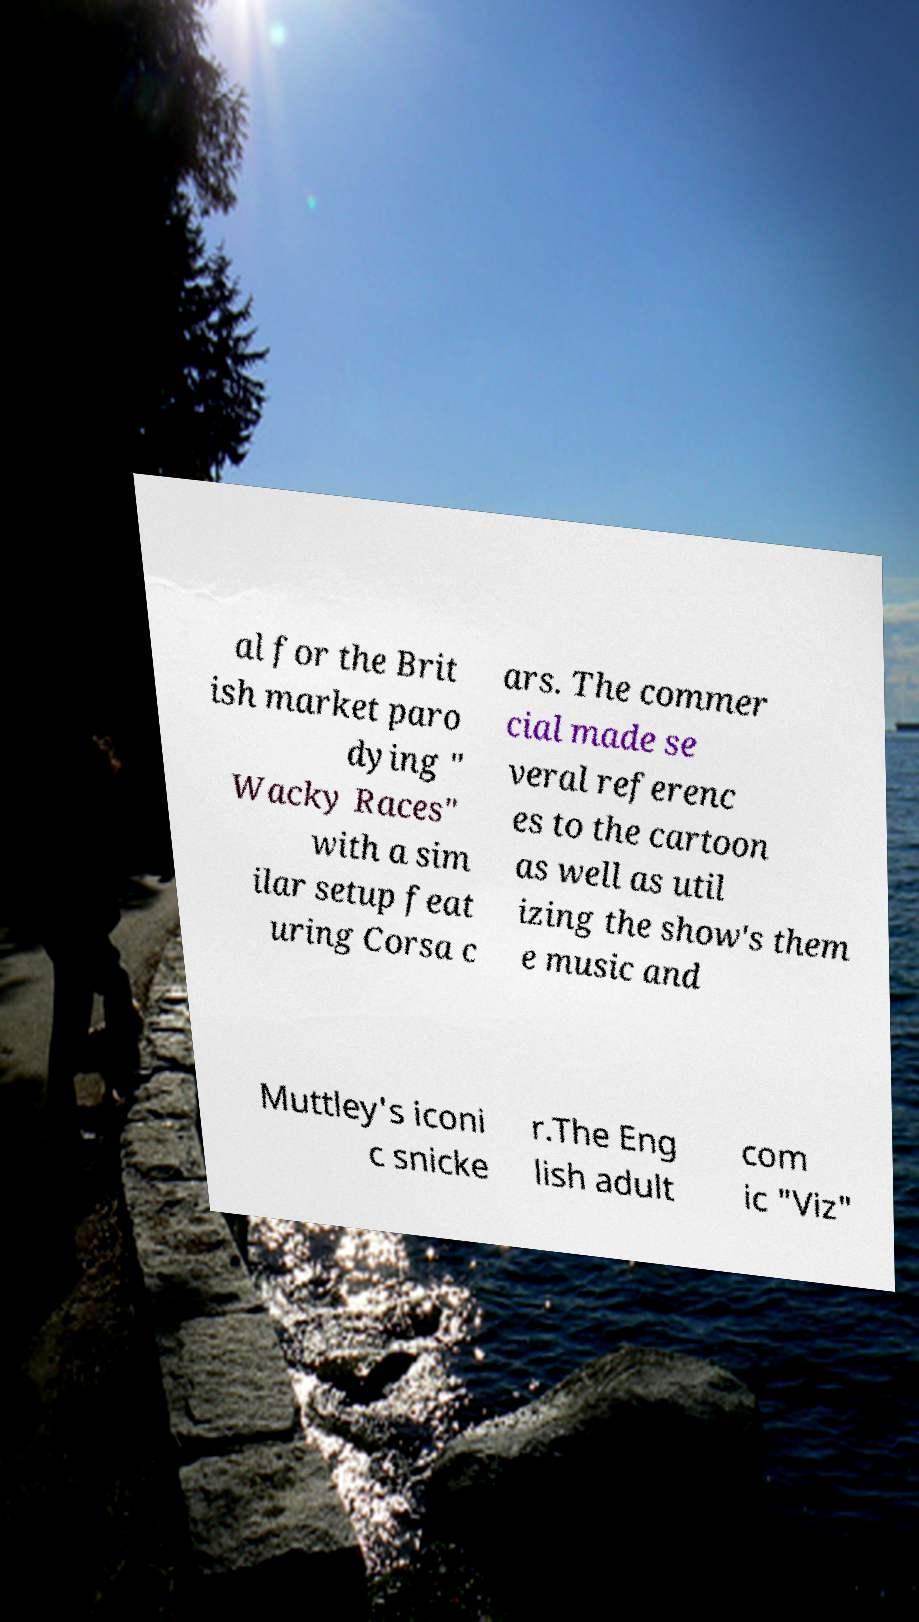What messages or text are displayed in this image? I need them in a readable, typed format. al for the Brit ish market paro dying " Wacky Races" with a sim ilar setup feat uring Corsa c ars. The commer cial made se veral referenc es to the cartoon as well as util izing the show's them e music and Muttley's iconi c snicke r.The Eng lish adult com ic "Viz" 